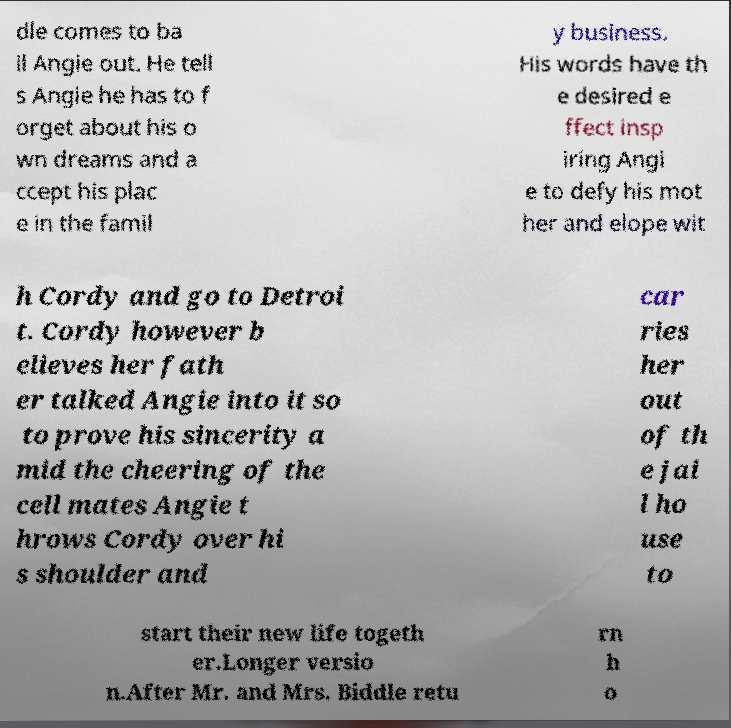Can you read and provide the text displayed in the image?This photo seems to have some interesting text. Can you extract and type it out for me? dle comes to ba il Angie out. He tell s Angie he has to f orget about his o wn dreams and a ccept his plac e in the famil y business. His words have th e desired e ffect insp iring Angi e to defy his mot her and elope wit h Cordy and go to Detroi t. Cordy however b elieves her fath er talked Angie into it so to prove his sincerity a mid the cheering of the cell mates Angie t hrows Cordy over hi s shoulder and car ries her out of th e jai l ho use to start their new life togeth er.Longer versio n.After Mr. and Mrs. Biddle retu rn h o 